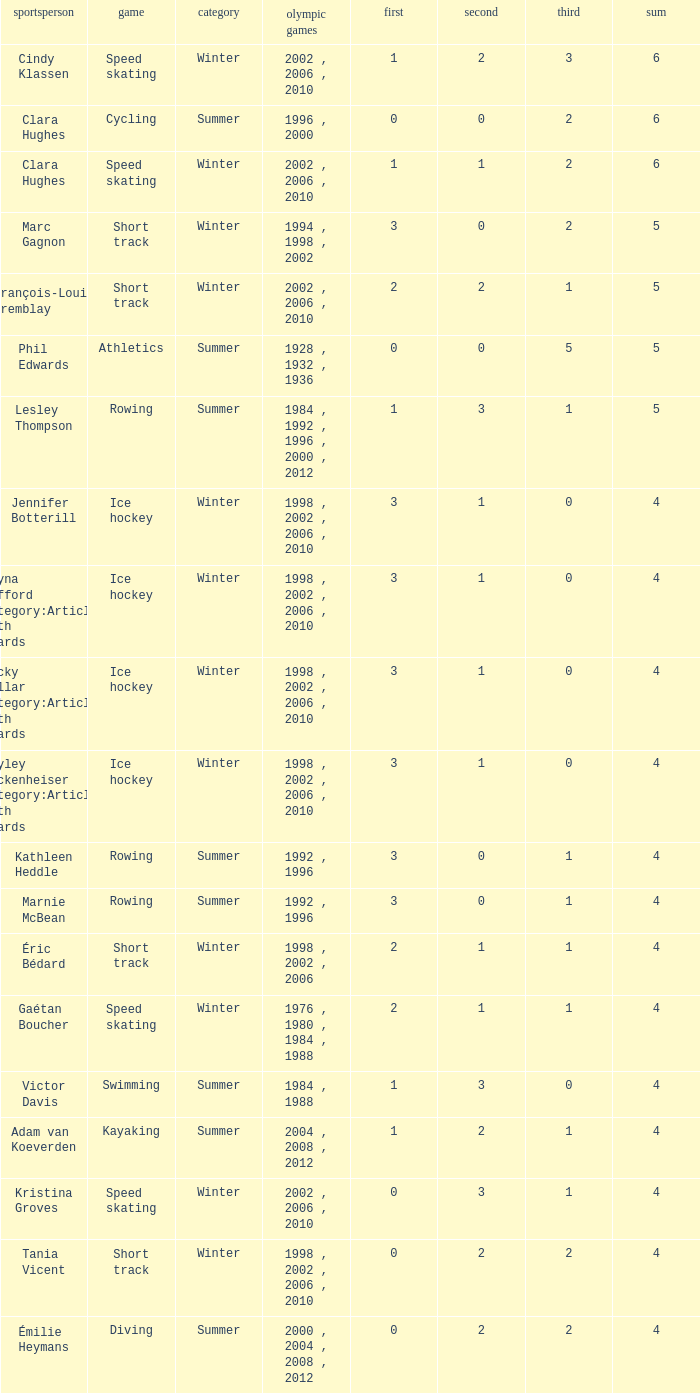What is the average gold of the winter athlete with 1 bronze, less than 3 silver, and less than 4 total medals? None. 